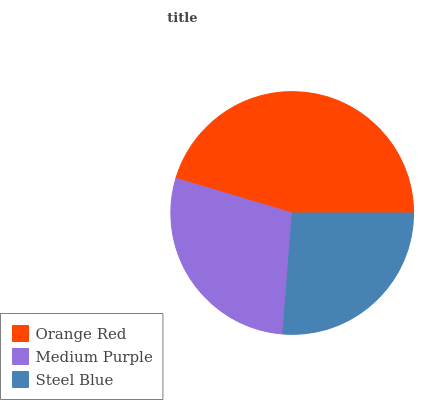Is Steel Blue the minimum?
Answer yes or no. Yes. Is Orange Red the maximum?
Answer yes or no. Yes. Is Medium Purple the minimum?
Answer yes or no. No. Is Medium Purple the maximum?
Answer yes or no. No. Is Orange Red greater than Medium Purple?
Answer yes or no. Yes. Is Medium Purple less than Orange Red?
Answer yes or no. Yes. Is Medium Purple greater than Orange Red?
Answer yes or no. No. Is Orange Red less than Medium Purple?
Answer yes or no. No. Is Medium Purple the high median?
Answer yes or no. Yes. Is Medium Purple the low median?
Answer yes or no. Yes. Is Steel Blue the high median?
Answer yes or no. No. Is Orange Red the low median?
Answer yes or no. No. 